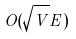Convert formula to latex. <formula><loc_0><loc_0><loc_500><loc_500>O ( \sqrt { V } E )</formula> 